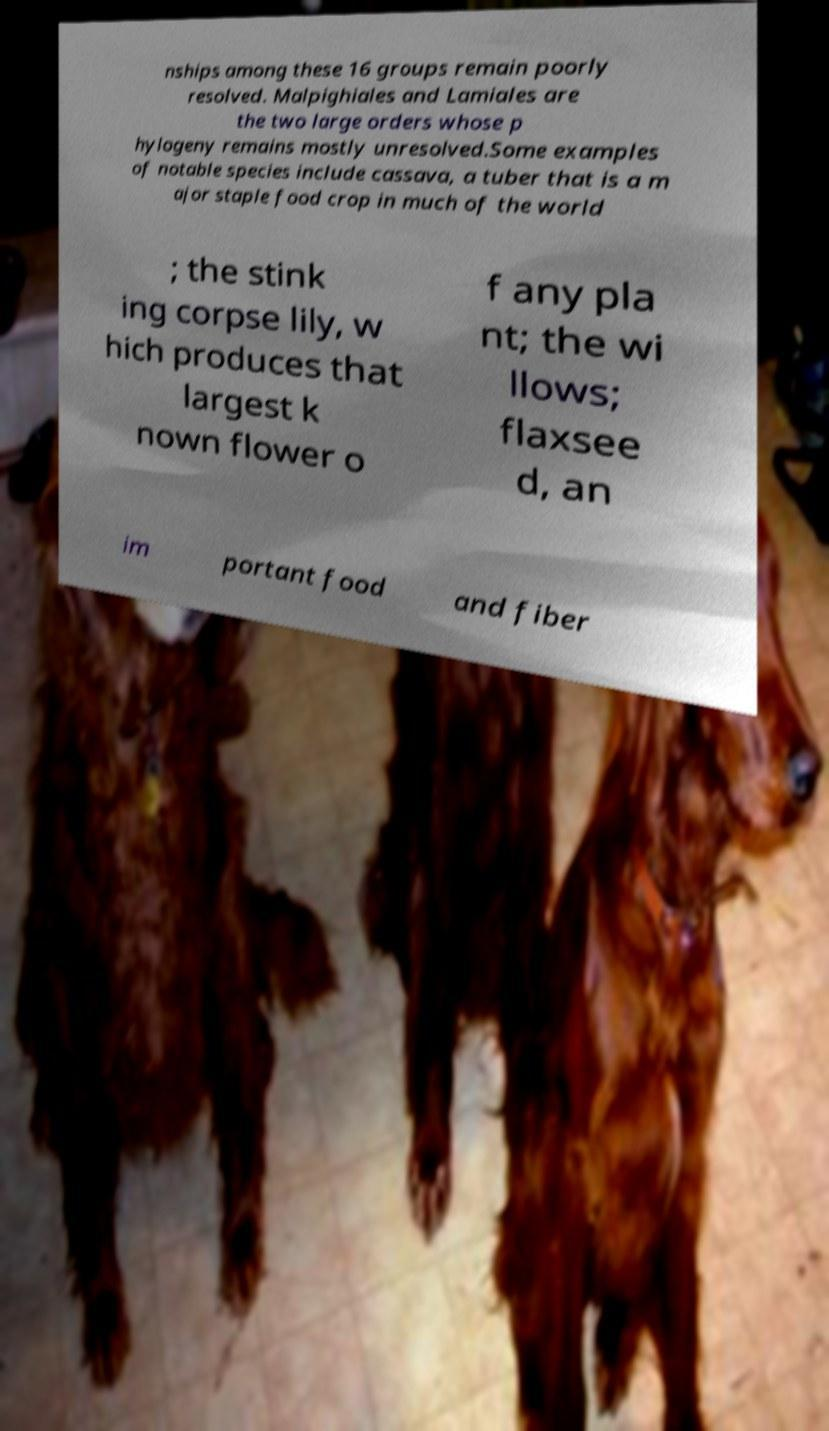Could you assist in decoding the text presented in this image and type it out clearly? nships among these 16 groups remain poorly resolved. Malpighiales and Lamiales are the two large orders whose p hylogeny remains mostly unresolved.Some examples of notable species include cassava, a tuber that is a m ajor staple food crop in much of the world ; the stink ing corpse lily, w hich produces that largest k nown flower o f any pla nt; the wi llows; flaxsee d, an im portant food and fiber 